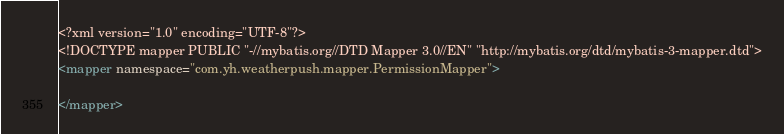<code> <loc_0><loc_0><loc_500><loc_500><_XML_><?xml version="1.0" encoding="UTF-8"?>
<!DOCTYPE mapper PUBLIC "-//mybatis.org//DTD Mapper 3.0//EN" "http://mybatis.org/dtd/mybatis-3-mapper.dtd">
<mapper namespace="com.yh.weatherpush.mapper.PermissionMapper">

</mapper>
</code> 